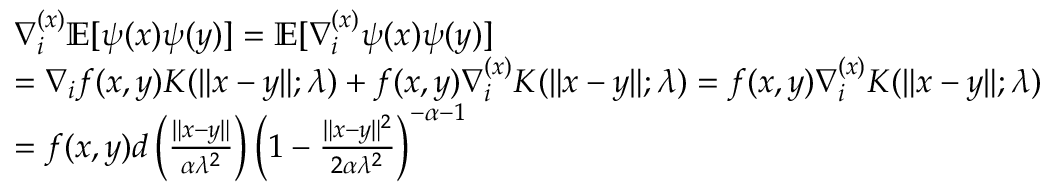Convert formula to latex. <formula><loc_0><loc_0><loc_500><loc_500>\begin{array} { r l } & { \nabla _ { i } ^ { ( x ) } \mathbb { E } [ \psi ( x ) \psi ( y ) ] = \mathbb { E } [ \nabla _ { i } ^ { ( x ) } \psi ( x ) \psi ( y ) ] } \\ & { = \nabla _ { i } f ( x , y ) K ( \| x - y \| ; \lambda ) + f ( x , y ) \nabla _ { i } ^ { ( x ) } K ( \| x - y \| ; \lambda ) = f ( x , y ) \nabla _ { i } ^ { ( x ) } K ( \| x - y \| ; \lambda ) } \\ & { = f ( x , y ) d \left ( \frac { \| x - y \| } { \alpha \lambda ^ { 2 } } \right ) \left ( 1 - \frac { \| x - y \| ^ { 2 } } { 2 \alpha \lambda ^ { 2 } } \right ) ^ { - \alpha - 1 } } \end{array}</formula> 